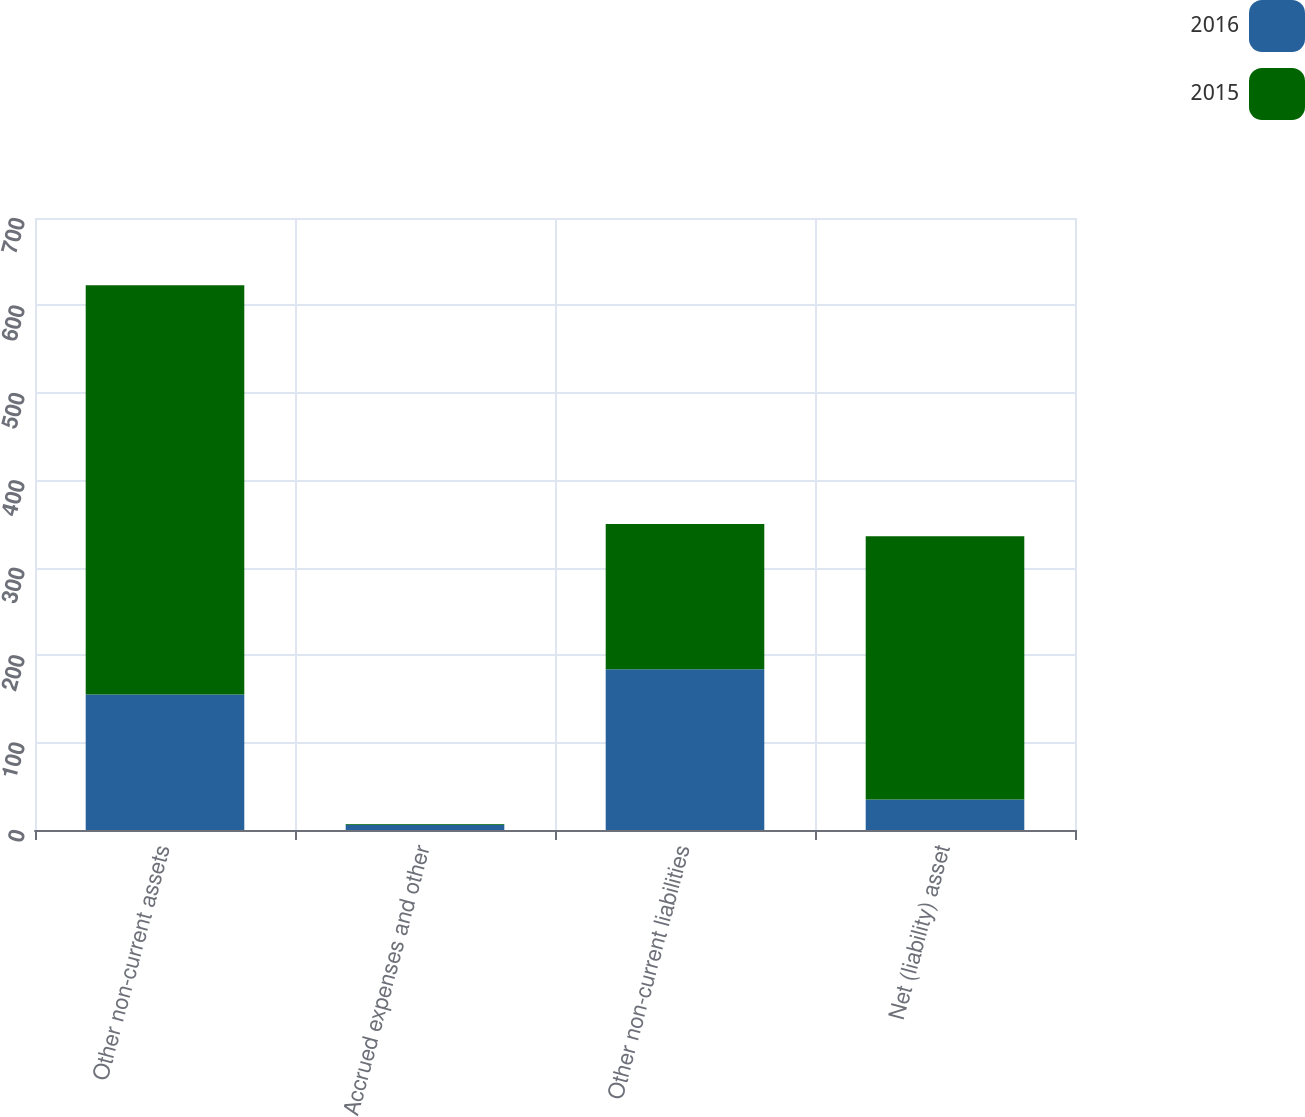Convert chart. <chart><loc_0><loc_0><loc_500><loc_500><stacked_bar_chart><ecel><fcel>Other non-current assets<fcel>Accrued expenses and other<fcel>Other non-current liabilities<fcel>Net (liability) asset<nl><fcel>2016<fcel>155<fcel>6<fcel>184<fcel>35<nl><fcel>2015<fcel>468<fcel>1<fcel>166<fcel>301<nl></chart> 